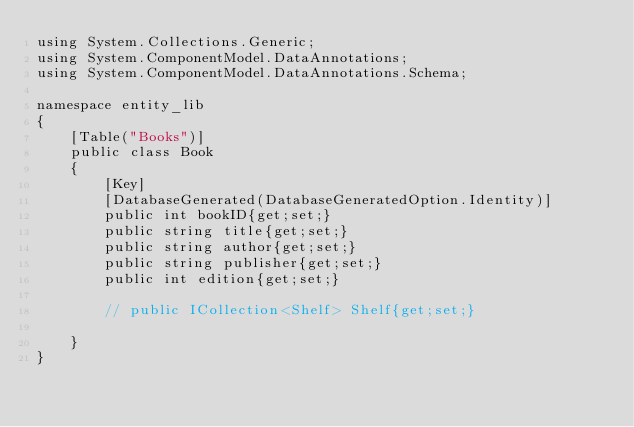<code> <loc_0><loc_0><loc_500><loc_500><_C#_>using System.Collections.Generic;
using System.ComponentModel.DataAnnotations;
using System.ComponentModel.DataAnnotations.Schema;

namespace entity_lib
{
    [Table("Books")]
    public class Book
    {
        [Key]
        [DatabaseGenerated(DatabaseGeneratedOption.Identity)]
        public int bookID{get;set;}
        public string title{get;set;}
        public string author{get;set;}
        public string publisher{get;set;}
        public int edition{get;set;}
        
        // public ICollection<Shelf> Shelf{get;set;}

    }
}</code> 